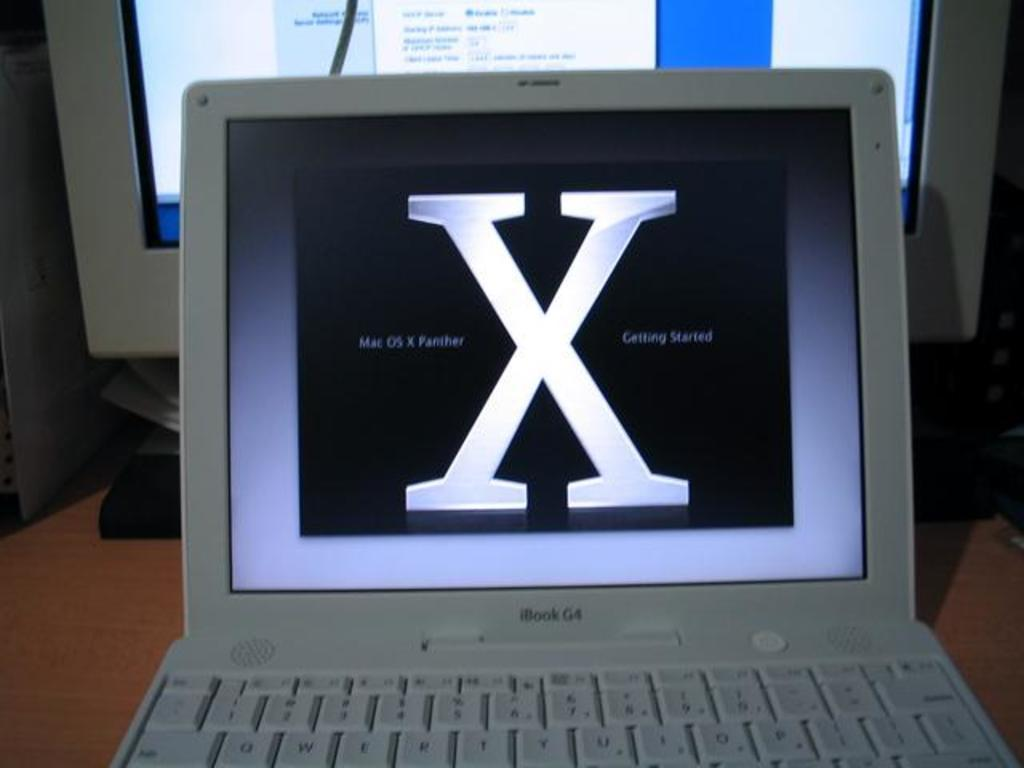What is the main subject of the image? The main subject of the image is a system. What electronic device is also visible in the image? There is a laptop in the image. What is the color of the surface on which the system and laptop are placed? The surface is brown in color. What type of band is playing music in the image? There is no band present in the image; it features a system and a laptop on a brown surface. Can you see a mitten in the image? There is no mitten present in the image. 